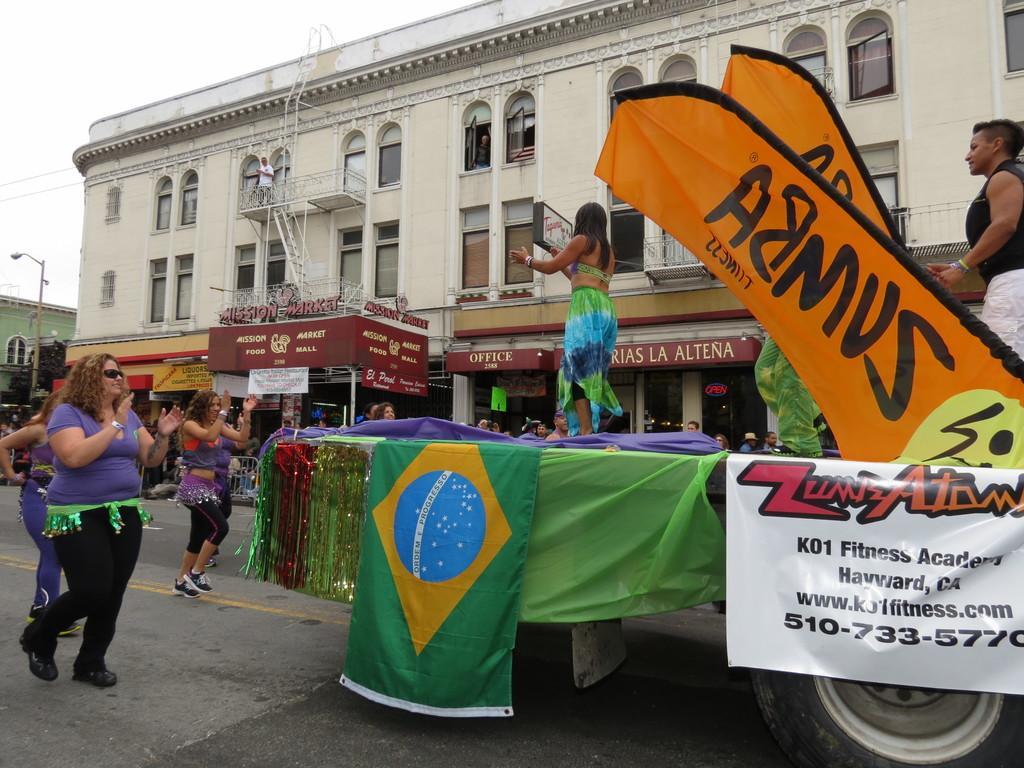Describe this image in one or two sentences. In this image I can see people dancing. Few people are standing on a vehicle. There are flags, banners and decorations on it. There are buildings at the back. A person is standing on a building, it has stairs and fence. There is sky at the top. 